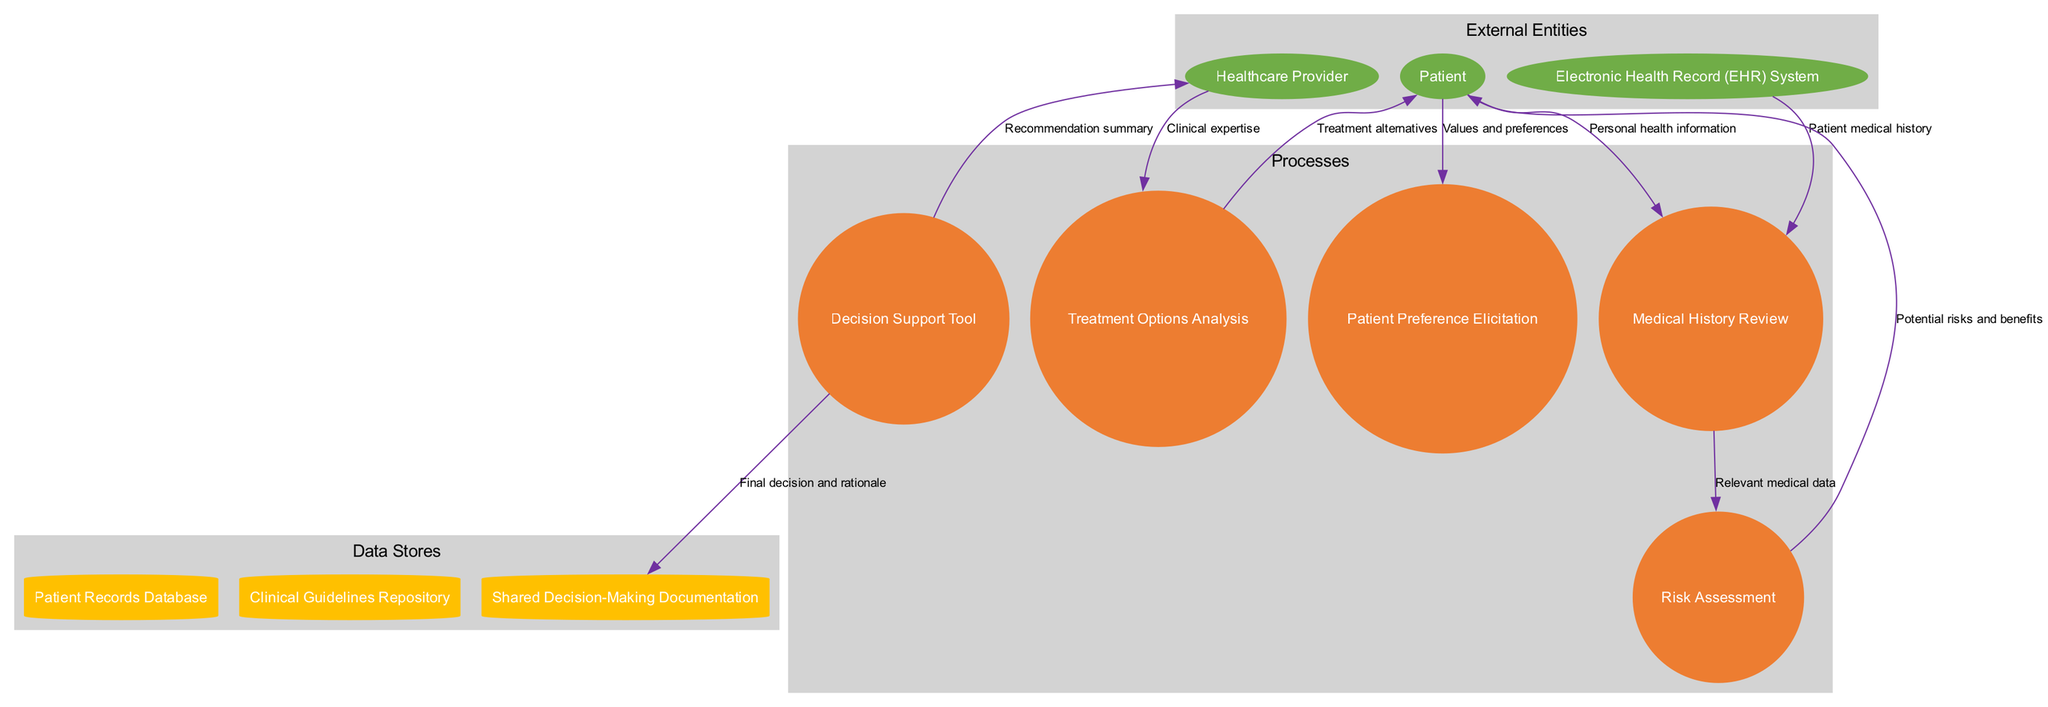What are the external entities represented in the diagram? The external entities in the diagram are listed and can be easily identified: Patient, Healthcare Provider, and Electronic Health Record System.
Answer: Patient, Healthcare Provider, Electronic Health Record System How many processes are depicted in the diagram? The processes are listed in the diagram, and by counting them, we find there are five distinct processes: Medical History Review, Treatment Options Analysis, Risk Assessment, Patient Preference Elicitation, and Decision Support Tool.
Answer: Five Which entity sends personal health information to the Medical History Review process? By examining the data flow, the Patient is identified as the entity that sends personal health information to the Medical History Review process.
Answer: Patient What is the data flow from the Treatment Options Analysis to the Patient? The arrows indicate the data flow direction, and from the Treatment Options Analysis to the Patient, the data is labeled as Treatment alternatives.
Answer: Treatment alternatives Which process is responsible for assessing risks and benefits? The Risk Assessment process is indicated as the one that evaluates potential risks and benefits based on the data flow relationships depicted in the diagram.
Answer: Risk Assessment What recommendation does the Decision Support Tool provide to the Healthcare Provider? The Decision Support Tool sends a Recommendation summary to the Healthcare Provider as indicated by the data flow labels.
Answer: Recommendation summary How many data stores are shown in the diagram? The diagram includes three data stores: Patient Records Database, Clinical Guidelines Repository, and Shared Decision-Making Documentation, which can be counted for a total.
Answer: Three What data is sent from the Risk Assessment to the Patient? The data flowing from Risk Assessment to the Patient is labeled as Potential risks and benefits, which directly reveals what information is passed along.
Answer: Potential risks and benefits What is the flow of data from the Decision Support Tool to the Shared Decision-Making Documentation? The Decision Support Tool sends the Final decision and rationale to the Shared Decision-Making Documentation, as indicated in the diagram.
Answer: Final decision and rationale 